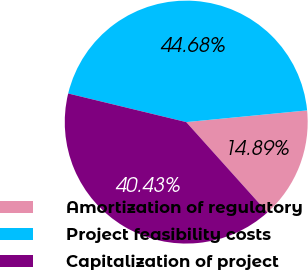Convert chart to OTSL. <chart><loc_0><loc_0><loc_500><loc_500><pie_chart><fcel>Amortization of regulatory<fcel>Project feasibility costs<fcel>Capitalization of project<nl><fcel>14.89%<fcel>44.68%<fcel>40.43%<nl></chart> 